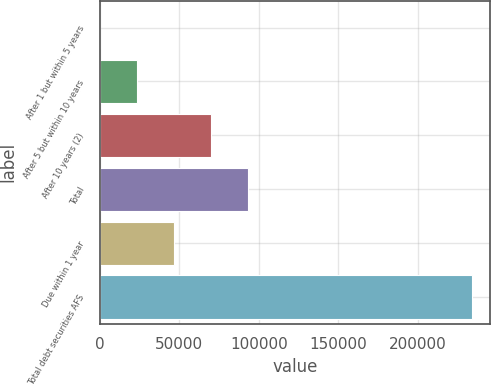Convert chart to OTSL. <chart><loc_0><loc_0><loc_500><loc_500><bar_chart><fcel>After 1 but within 5 years<fcel>After 5 but within 10 years<fcel>After 10 years (2)<fcel>Total<fcel>Due within 1 year<fcel>Total debt securities AFS<nl><fcel>16<fcel>23393.7<fcel>70149.1<fcel>93526.8<fcel>46771.4<fcel>233793<nl></chart> 